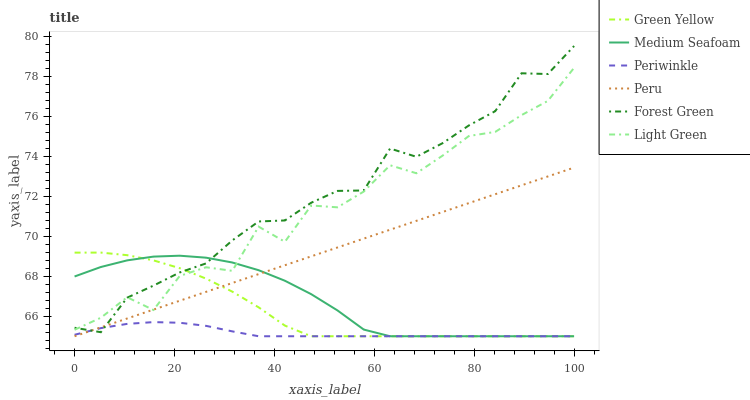Does Forest Green have the minimum area under the curve?
Answer yes or no. No. Does Periwinkle have the maximum area under the curve?
Answer yes or no. No. Is Forest Green the smoothest?
Answer yes or no. No. Is Forest Green the roughest?
Answer yes or no. No. Does Forest Green have the lowest value?
Answer yes or no. No. Does Periwinkle have the highest value?
Answer yes or no. No. Is Periwinkle less than Light Green?
Answer yes or no. Yes. Is Light Green greater than Periwinkle?
Answer yes or no. Yes. Does Periwinkle intersect Light Green?
Answer yes or no. No. 